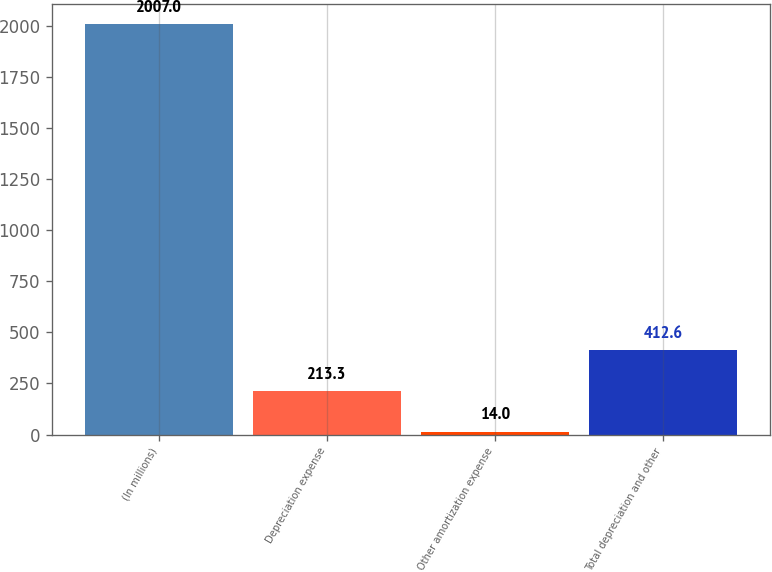Convert chart. <chart><loc_0><loc_0><loc_500><loc_500><bar_chart><fcel>(In millions)<fcel>Depreciation expense<fcel>Other amortization expense<fcel>Total depreciation and other<nl><fcel>2007<fcel>213.3<fcel>14<fcel>412.6<nl></chart> 